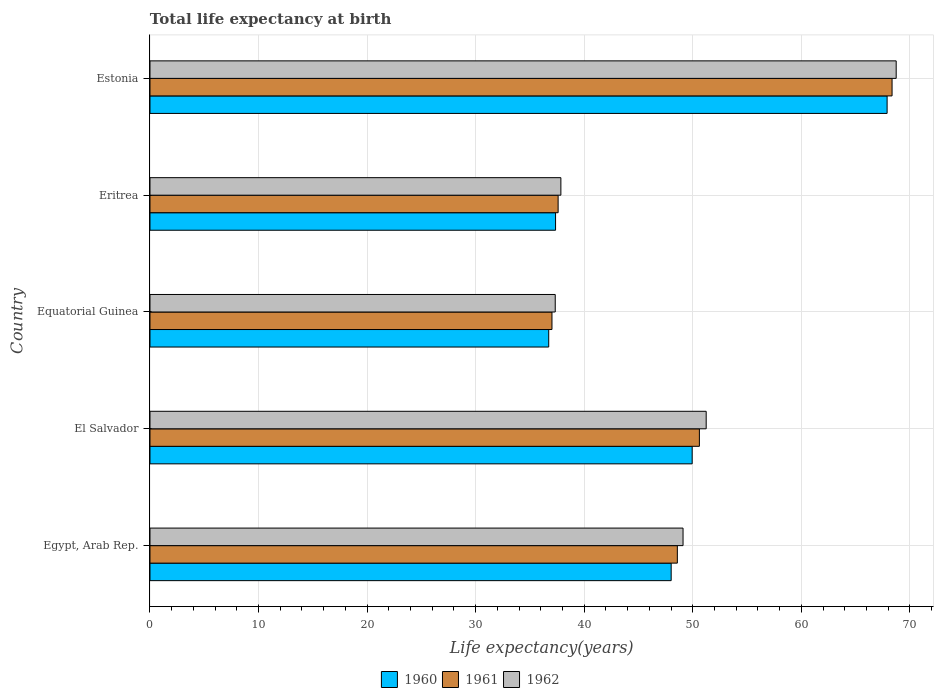How many different coloured bars are there?
Your answer should be very brief. 3. Are the number of bars on each tick of the Y-axis equal?
Give a very brief answer. Yes. How many bars are there on the 3rd tick from the bottom?
Provide a succinct answer. 3. What is the label of the 5th group of bars from the top?
Your response must be concise. Egypt, Arab Rep. In how many cases, is the number of bars for a given country not equal to the number of legend labels?
Make the answer very short. 0. What is the life expectancy at birth in in 1962 in El Salvador?
Offer a very short reply. 51.24. Across all countries, what is the maximum life expectancy at birth in in 1960?
Give a very brief answer. 67.91. Across all countries, what is the minimum life expectancy at birth in in 1960?
Your answer should be compact. 36.73. In which country was the life expectancy at birth in in 1961 maximum?
Your answer should be compact. Estonia. In which country was the life expectancy at birth in in 1960 minimum?
Keep it short and to the point. Equatorial Guinea. What is the total life expectancy at birth in in 1961 in the graph?
Your answer should be compact. 242.19. What is the difference between the life expectancy at birth in in 1962 in El Salvador and that in Estonia?
Make the answer very short. -17.5. What is the difference between the life expectancy at birth in in 1961 in Eritrea and the life expectancy at birth in in 1962 in Estonia?
Ensure brevity in your answer.  -31.14. What is the average life expectancy at birth in in 1962 per country?
Your answer should be very brief. 48.85. What is the difference between the life expectancy at birth in in 1961 and life expectancy at birth in in 1960 in El Salvador?
Provide a short and direct response. 0.66. In how many countries, is the life expectancy at birth in in 1960 greater than 6 years?
Your response must be concise. 5. What is the ratio of the life expectancy at birth in in 1962 in Equatorial Guinea to that in Eritrea?
Your answer should be compact. 0.99. Is the life expectancy at birth in in 1962 in Egypt, Arab Rep. less than that in El Salvador?
Your answer should be very brief. Yes. What is the difference between the highest and the second highest life expectancy at birth in in 1960?
Offer a very short reply. 17.96. What is the difference between the highest and the lowest life expectancy at birth in in 1961?
Give a very brief answer. 31.33. In how many countries, is the life expectancy at birth in in 1960 greater than the average life expectancy at birth in in 1960 taken over all countries?
Offer a terse response. 3. Is it the case that in every country, the sum of the life expectancy at birth in in 1961 and life expectancy at birth in in 1962 is greater than the life expectancy at birth in in 1960?
Provide a short and direct response. Yes. How many bars are there?
Your response must be concise. 15. How many countries are there in the graph?
Your answer should be compact. 5. What is the difference between two consecutive major ticks on the X-axis?
Give a very brief answer. 10. Does the graph contain any zero values?
Give a very brief answer. No. What is the title of the graph?
Make the answer very short. Total life expectancy at birth. Does "2003" appear as one of the legend labels in the graph?
Offer a terse response. No. What is the label or title of the X-axis?
Your answer should be compact. Life expectancy(years). What is the Life expectancy(years) in 1960 in Egypt, Arab Rep.?
Make the answer very short. 48.01. What is the Life expectancy(years) in 1961 in Egypt, Arab Rep.?
Your answer should be compact. 48.58. What is the Life expectancy(years) in 1962 in Egypt, Arab Rep.?
Offer a very short reply. 49.11. What is the Life expectancy(years) of 1960 in El Salvador?
Provide a short and direct response. 49.95. What is the Life expectancy(years) in 1961 in El Salvador?
Provide a short and direct response. 50.61. What is the Life expectancy(years) of 1962 in El Salvador?
Provide a succinct answer. 51.24. What is the Life expectancy(years) in 1960 in Equatorial Guinea?
Give a very brief answer. 36.73. What is the Life expectancy(years) in 1961 in Equatorial Guinea?
Keep it short and to the point. 37.03. What is the Life expectancy(years) of 1962 in Equatorial Guinea?
Your answer should be compact. 37.33. What is the Life expectancy(years) of 1960 in Eritrea?
Provide a succinct answer. 37.36. What is the Life expectancy(years) in 1961 in Eritrea?
Offer a terse response. 37.6. What is the Life expectancy(years) in 1962 in Eritrea?
Offer a terse response. 37.85. What is the Life expectancy(years) of 1960 in Estonia?
Make the answer very short. 67.91. What is the Life expectancy(years) in 1961 in Estonia?
Your answer should be very brief. 68.36. What is the Life expectancy(years) of 1962 in Estonia?
Give a very brief answer. 68.74. Across all countries, what is the maximum Life expectancy(years) of 1960?
Your response must be concise. 67.91. Across all countries, what is the maximum Life expectancy(years) of 1961?
Ensure brevity in your answer.  68.36. Across all countries, what is the maximum Life expectancy(years) of 1962?
Your answer should be very brief. 68.74. Across all countries, what is the minimum Life expectancy(years) in 1960?
Provide a succinct answer. 36.73. Across all countries, what is the minimum Life expectancy(years) in 1961?
Make the answer very short. 37.03. Across all countries, what is the minimum Life expectancy(years) of 1962?
Your answer should be compact. 37.33. What is the total Life expectancy(years) of 1960 in the graph?
Give a very brief answer. 239.96. What is the total Life expectancy(years) of 1961 in the graph?
Your response must be concise. 242.19. What is the total Life expectancy(years) of 1962 in the graph?
Offer a very short reply. 244.27. What is the difference between the Life expectancy(years) of 1960 in Egypt, Arab Rep. and that in El Salvador?
Make the answer very short. -1.93. What is the difference between the Life expectancy(years) in 1961 in Egypt, Arab Rep. and that in El Salvador?
Make the answer very short. -2.03. What is the difference between the Life expectancy(years) in 1962 in Egypt, Arab Rep. and that in El Salvador?
Your answer should be compact. -2.13. What is the difference between the Life expectancy(years) in 1960 in Egypt, Arab Rep. and that in Equatorial Guinea?
Keep it short and to the point. 11.28. What is the difference between the Life expectancy(years) of 1961 in Egypt, Arab Rep. and that in Equatorial Guinea?
Give a very brief answer. 11.55. What is the difference between the Life expectancy(years) of 1962 in Egypt, Arab Rep. and that in Equatorial Guinea?
Offer a terse response. 11.77. What is the difference between the Life expectancy(years) in 1960 in Egypt, Arab Rep. and that in Eritrea?
Give a very brief answer. 10.65. What is the difference between the Life expectancy(years) of 1961 in Egypt, Arab Rep. and that in Eritrea?
Offer a very short reply. 10.98. What is the difference between the Life expectancy(years) in 1962 in Egypt, Arab Rep. and that in Eritrea?
Make the answer very short. 11.25. What is the difference between the Life expectancy(years) in 1960 in Egypt, Arab Rep. and that in Estonia?
Provide a short and direct response. -19.89. What is the difference between the Life expectancy(years) in 1961 in Egypt, Arab Rep. and that in Estonia?
Your answer should be very brief. -19.78. What is the difference between the Life expectancy(years) of 1962 in Egypt, Arab Rep. and that in Estonia?
Make the answer very short. -19.64. What is the difference between the Life expectancy(years) in 1960 in El Salvador and that in Equatorial Guinea?
Offer a very short reply. 13.21. What is the difference between the Life expectancy(years) in 1961 in El Salvador and that in Equatorial Guinea?
Provide a short and direct response. 13.58. What is the difference between the Life expectancy(years) of 1962 in El Salvador and that in Equatorial Guinea?
Provide a succinct answer. 13.91. What is the difference between the Life expectancy(years) of 1960 in El Salvador and that in Eritrea?
Make the answer very short. 12.59. What is the difference between the Life expectancy(years) in 1961 in El Salvador and that in Eritrea?
Your response must be concise. 13.01. What is the difference between the Life expectancy(years) in 1962 in El Salvador and that in Eritrea?
Offer a very short reply. 13.39. What is the difference between the Life expectancy(years) of 1960 in El Salvador and that in Estonia?
Offer a very short reply. -17.96. What is the difference between the Life expectancy(years) in 1961 in El Salvador and that in Estonia?
Your answer should be compact. -17.75. What is the difference between the Life expectancy(years) of 1962 in El Salvador and that in Estonia?
Your answer should be very brief. -17.5. What is the difference between the Life expectancy(years) in 1960 in Equatorial Guinea and that in Eritrea?
Keep it short and to the point. -0.63. What is the difference between the Life expectancy(years) in 1961 in Equatorial Guinea and that in Eritrea?
Offer a very short reply. -0.57. What is the difference between the Life expectancy(years) in 1962 in Equatorial Guinea and that in Eritrea?
Keep it short and to the point. -0.52. What is the difference between the Life expectancy(years) in 1960 in Equatorial Guinea and that in Estonia?
Provide a short and direct response. -31.17. What is the difference between the Life expectancy(years) in 1961 in Equatorial Guinea and that in Estonia?
Give a very brief answer. -31.33. What is the difference between the Life expectancy(years) in 1962 in Equatorial Guinea and that in Estonia?
Ensure brevity in your answer.  -31.41. What is the difference between the Life expectancy(years) of 1960 in Eritrea and that in Estonia?
Your answer should be very brief. -30.54. What is the difference between the Life expectancy(years) in 1961 in Eritrea and that in Estonia?
Offer a terse response. -30.76. What is the difference between the Life expectancy(years) in 1962 in Eritrea and that in Estonia?
Ensure brevity in your answer.  -30.89. What is the difference between the Life expectancy(years) of 1960 in Egypt, Arab Rep. and the Life expectancy(years) of 1961 in El Salvador?
Your answer should be very brief. -2.6. What is the difference between the Life expectancy(years) in 1960 in Egypt, Arab Rep. and the Life expectancy(years) in 1962 in El Salvador?
Offer a very short reply. -3.23. What is the difference between the Life expectancy(years) of 1961 in Egypt, Arab Rep. and the Life expectancy(years) of 1962 in El Salvador?
Your response must be concise. -2.66. What is the difference between the Life expectancy(years) in 1960 in Egypt, Arab Rep. and the Life expectancy(years) in 1961 in Equatorial Guinea?
Make the answer very short. 10.98. What is the difference between the Life expectancy(years) in 1960 in Egypt, Arab Rep. and the Life expectancy(years) in 1962 in Equatorial Guinea?
Your answer should be compact. 10.68. What is the difference between the Life expectancy(years) in 1961 in Egypt, Arab Rep. and the Life expectancy(years) in 1962 in Equatorial Guinea?
Your answer should be compact. 11.25. What is the difference between the Life expectancy(years) in 1960 in Egypt, Arab Rep. and the Life expectancy(years) in 1961 in Eritrea?
Offer a very short reply. 10.41. What is the difference between the Life expectancy(years) in 1960 in Egypt, Arab Rep. and the Life expectancy(years) in 1962 in Eritrea?
Provide a short and direct response. 10.16. What is the difference between the Life expectancy(years) in 1961 in Egypt, Arab Rep. and the Life expectancy(years) in 1962 in Eritrea?
Ensure brevity in your answer.  10.73. What is the difference between the Life expectancy(years) in 1960 in Egypt, Arab Rep. and the Life expectancy(years) in 1961 in Estonia?
Give a very brief answer. -20.35. What is the difference between the Life expectancy(years) of 1960 in Egypt, Arab Rep. and the Life expectancy(years) of 1962 in Estonia?
Your answer should be compact. -20.73. What is the difference between the Life expectancy(years) in 1961 in Egypt, Arab Rep. and the Life expectancy(years) in 1962 in Estonia?
Make the answer very short. -20.16. What is the difference between the Life expectancy(years) in 1960 in El Salvador and the Life expectancy(years) in 1961 in Equatorial Guinea?
Keep it short and to the point. 12.92. What is the difference between the Life expectancy(years) of 1960 in El Salvador and the Life expectancy(years) of 1962 in Equatorial Guinea?
Your answer should be very brief. 12.62. What is the difference between the Life expectancy(years) of 1961 in El Salvador and the Life expectancy(years) of 1962 in Equatorial Guinea?
Offer a terse response. 13.28. What is the difference between the Life expectancy(years) in 1960 in El Salvador and the Life expectancy(years) in 1961 in Eritrea?
Your response must be concise. 12.35. What is the difference between the Life expectancy(years) of 1960 in El Salvador and the Life expectancy(years) of 1962 in Eritrea?
Your answer should be very brief. 12.1. What is the difference between the Life expectancy(years) in 1961 in El Salvador and the Life expectancy(years) in 1962 in Eritrea?
Provide a succinct answer. 12.76. What is the difference between the Life expectancy(years) in 1960 in El Salvador and the Life expectancy(years) in 1961 in Estonia?
Ensure brevity in your answer.  -18.41. What is the difference between the Life expectancy(years) of 1960 in El Salvador and the Life expectancy(years) of 1962 in Estonia?
Ensure brevity in your answer.  -18.79. What is the difference between the Life expectancy(years) of 1961 in El Salvador and the Life expectancy(years) of 1962 in Estonia?
Ensure brevity in your answer.  -18.13. What is the difference between the Life expectancy(years) in 1960 in Equatorial Guinea and the Life expectancy(years) in 1961 in Eritrea?
Keep it short and to the point. -0.87. What is the difference between the Life expectancy(years) of 1960 in Equatorial Guinea and the Life expectancy(years) of 1962 in Eritrea?
Make the answer very short. -1.12. What is the difference between the Life expectancy(years) in 1961 in Equatorial Guinea and the Life expectancy(years) in 1962 in Eritrea?
Offer a very short reply. -0.82. What is the difference between the Life expectancy(years) of 1960 in Equatorial Guinea and the Life expectancy(years) of 1961 in Estonia?
Give a very brief answer. -31.63. What is the difference between the Life expectancy(years) of 1960 in Equatorial Guinea and the Life expectancy(years) of 1962 in Estonia?
Offer a terse response. -32.01. What is the difference between the Life expectancy(years) in 1961 in Equatorial Guinea and the Life expectancy(years) in 1962 in Estonia?
Provide a succinct answer. -31.71. What is the difference between the Life expectancy(years) of 1960 in Eritrea and the Life expectancy(years) of 1961 in Estonia?
Offer a very short reply. -31. What is the difference between the Life expectancy(years) in 1960 in Eritrea and the Life expectancy(years) in 1962 in Estonia?
Ensure brevity in your answer.  -31.38. What is the difference between the Life expectancy(years) in 1961 in Eritrea and the Life expectancy(years) in 1962 in Estonia?
Give a very brief answer. -31.14. What is the average Life expectancy(years) of 1960 per country?
Give a very brief answer. 47.99. What is the average Life expectancy(years) in 1961 per country?
Provide a succinct answer. 48.44. What is the average Life expectancy(years) in 1962 per country?
Keep it short and to the point. 48.85. What is the difference between the Life expectancy(years) in 1960 and Life expectancy(years) in 1961 in Egypt, Arab Rep.?
Offer a very short reply. -0.57. What is the difference between the Life expectancy(years) in 1960 and Life expectancy(years) in 1962 in Egypt, Arab Rep.?
Your answer should be very brief. -1.09. What is the difference between the Life expectancy(years) of 1961 and Life expectancy(years) of 1962 in Egypt, Arab Rep.?
Your answer should be compact. -0.52. What is the difference between the Life expectancy(years) in 1960 and Life expectancy(years) in 1961 in El Salvador?
Make the answer very short. -0.66. What is the difference between the Life expectancy(years) in 1960 and Life expectancy(years) in 1962 in El Salvador?
Offer a terse response. -1.29. What is the difference between the Life expectancy(years) in 1961 and Life expectancy(years) in 1962 in El Salvador?
Offer a terse response. -0.63. What is the difference between the Life expectancy(years) in 1960 and Life expectancy(years) in 1961 in Equatorial Guinea?
Give a very brief answer. -0.3. What is the difference between the Life expectancy(years) in 1960 and Life expectancy(years) in 1962 in Equatorial Guinea?
Your answer should be compact. -0.6. What is the difference between the Life expectancy(years) in 1961 and Life expectancy(years) in 1962 in Equatorial Guinea?
Offer a very short reply. -0.3. What is the difference between the Life expectancy(years) in 1960 and Life expectancy(years) in 1961 in Eritrea?
Offer a terse response. -0.24. What is the difference between the Life expectancy(years) of 1960 and Life expectancy(years) of 1962 in Eritrea?
Offer a terse response. -0.49. What is the difference between the Life expectancy(years) in 1961 and Life expectancy(years) in 1962 in Eritrea?
Keep it short and to the point. -0.25. What is the difference between the Life expectancy(years) in 1960 and Life expectancy(years) in 1961 in Estonia?
Make the answer very short. -0.46. What is the difference between the Life expectancy(years) of 1960 and Life expectancy(years) of 1962 in Estonia?
Offer a terse response. -0.84. What is the difference between the Life expectancy(years) in 1961 and Life expectancy(years) in 1962 in Estonia?
Give a very brief answer. -0.38. What is the ratio of the Life expectancy(years) of 1960 in Egypt, Arab Rep. to that in El Salvador?
Your answer should be very brief. 0.96. What is the ratio of the Life expectancy(years) of 1961 in Egypt, Arab Rep. to that in El Salvador?
Ensure brevity in your answer.  0.96. What is the ratio of the Life expectancy(years) in 1962 in Egypt, Arab Rep. to that in El Salvador?
Offer a terse response. 0.96. What is the ratio of the Life expectancy(years) in 1960 in Egypt, Arab Rep. to that in Equatorial Guinea?
Make the answer very short. 1.31. What is the ratio of the Life expectancy(years) in 1961 in Egypt, Arab Rep. to that in Equatorial Guinea?
Offer a very short reply. 1.31. What is the ratio of the Life expectancy(years) of 1962 in Egypt, Arab Rep. to that in Equatorial Guinea?
Offer a terse response. 1.32. What is the ratio of the Life expectancy(years) in 1960 in Egypt, Arab Rep. to that in Eritrea?
Give a very brief answer. 1.29. What is the ratio of the Life expectancy(years) in 1961 in Egypt, Arab Rep. to that in Eritrea?
Make the answer very short. 1.29. What is the ratio of the Life expectancy(years) of 1962 in Egypt, Arab Rep. to that in Eritrea?
Keep it short and to the point. 1.3. What is the ratio of the Life expectancy(years) of 1960 in Egypt, Arab Rep. to that in Estonia?
Your answer should be very brief. 0.71. What is the ratio of the Life expectancy(years) in 1961 in Egypt, Arab Rep. to that in Estonia?
Keep it short and to the point. 0.71. What is the ratio of the Life expectancy(years) in 1962 in Egypt, Arab Rep. to that in Estonia?
Offer a terse response. 0.71. What is the ratio of the Life expectancy(years) in 1960 in El Salvador to that in Equatorial Guinea?
Your response must be concise. 1.36. What is the ratio of the Life expectancy(years) of 1961 in El Salvador to that in Equatorial Guinea?
Give a very brief answer. 1.37. What is the ratio of the Life expectancy(years) in 1962 in El Salvador to that in Equatorial Guinea?
Provide a short and direct response. 1.37. What is the ratio of the Life expectancy(years) of 1960 in El Salvador to that in Eritrea?
Your response must be concise. 1.34. What is the ratio of the Life expectancy(years) of 1961 in El Salvador to that in Eritrea?
Keep it short and to the point. 1.35. What is the ratio of the Life expectancy(years) in 1962 in El Salvador to that in Eritrea?
Your answer should be very brief. 1.35. What is the ratio of the Life expectancy(years) in 1960 in El Salvador to that in Estonia?
Ensure brevity in your answer.  0.74. What is the ratio of the Life expectancy(years) of 1961 in El Salvador to that in Estonia?
Offer a very short reply. 0.74. What is the ratio of the Life expectancy(years) in 1962 in El Salvador to that in Estonia?
Keep it short and to the point. 0.75. What is the ratio of the Life expectancy(years) in 1960 in Equatorial Guinea to that in Eritrea?
Your answer should be very brief. 0.98. What is the ratio of the Life expectancy(years) of 1961 in Equatorial Guinea to that in Eritrea?
Keep it short and to the point. 0.98. What is the ratio of the Life expectancy(years) of 1962 in Equatorial Guinea to that in Eritrea?
Give a very brief answer. 0.99. What is the ratio of the Life expectancy(years) in 1960 in Equatorial Guinea to that in Estonia?
Offer a terse response. 0.54. What is the ratio of the Life expectancy(years) of 1961 in Equatorial Guinea to that in Estonia?
Ensure brevity in your answer.  0.54. What is the ratio of the Life expectancy(years) in 1962 in Equatorial Guinea to that in Estonia?
Your answer should be compact. 0.54. What is the ratio of the Life expectancy(years) of 1960 in Eritrea to that in Estonia?
Ensure brevity in your answer.  0.55. What is the ratio of the Life expectancy(years) in 1961 in Eritrea to that in Estonia?
Offer a terse response. 0.55. What is the ratio of the Life expectancy(years) in 1962 in Eritrea to that in Estonia?
Make the answer very short. 0.55. What is the difference between the highest and the second highest Life expectancy(years) in 1960?
Provide a short and direct response. 17.96. What is the difference between the highest and the second highest Life expectancy(years) in 1961?
Ensure brevity in your answer.  17.75. What is the difference between the highest and the second highest Life expectancy(years) in 1962?
Offer a very short reply. 17.5. What is the difference between the highest and the lowest Life expectancy(years) of 1960?
Your answer should be compact. 31.17. What is the difference between the highest and the lowest Life expectancy(years) of 1961?
Your answer should be compact. 31.33. What is the difference between the highest and the lowest Life expectancy(years) in 1962?
Make the answer very short. 31.41. 